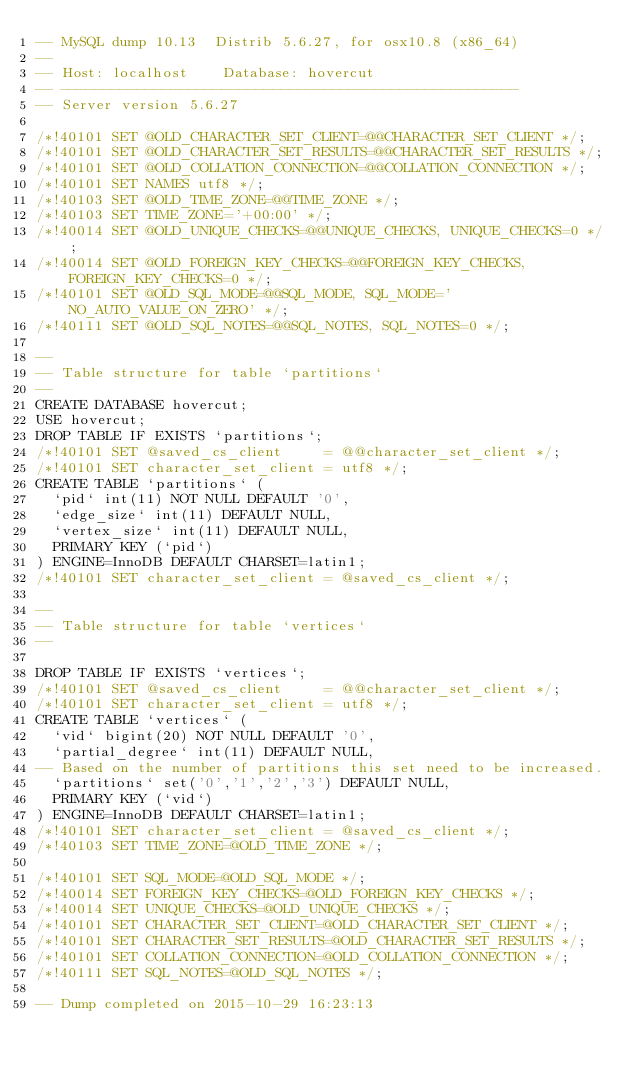Convert code to text. <code><loc_0><loc_0><loc_500><loc_500><_SQL_>-- MySQL dump 10.13  Distrib 5.6.27, for osx10.8 (x86_64)
--
-- Host: localhost    Database: hovercut
-- ------------------------------------------------------
-- Server version	5.6.27

/*!40101 SET @OLD_CHARACTER_SET_CLIENT=@@CHARACTER_SET_CLIENT */;
/*!40101 SET @OLD_CHARACTER_SET_RESULTS=@@CHARACTER_SET_RESULTS */;
/*!40101 SET @OLD_COLLATION_CONNECTION=@@COLLATION_CONNECTION */;
/*!40101 SET NAMES utf8 */;
/*!40103 SET @OLD_TIME_ZONE=@@TIME_ZONE */;
/*!40103 SET TIME_ZONE='+00:00' */;
/*!40014 SET @OLD_UNIQUE_CHECKS=@@UNIQUE_CHECKS, UNIQUE_CHECKS=0 */;
/*!40014 SET @OLD_FOREIGN_KEY_CHECKS=@@FOREIGN_KEY_CHECKS, FOREIGN_KEY_CHECKS=0 */;
/*!40101 SET @OLD_SQL_MODE=@@SQL_MODE, SQL_MODE='NO_AUTO_VALUE_ON_ZERO' */;
/*!40111 SET @OLD_SQL_NOTES=@@SQL_NOTES, SQL_NOTES=0 */;

--
-- Table structure for table `partitions`
--
CREATE DATABASE hovercut;
USE hovercut;
DROP TABLE IF EXISTS `partitions`;
/*!40101 SET @saved_cs_client     = @@character_set_client */;
/*!40101 SET character_set_client = utf8 */;
CREATE TABLE `partitions` (
  `pid` int(11) NOT NULL DEFAULT '0',
  `edge_size` int(11) DEFAULT NULL,
  `vertex_size` int(11) DEFAULT NULL,
  PRIMARY KEY (`pid`)
) ENGINE=InnoDB DEFAULT CHARSET=latin1;
/*!40101 SET character_set_client = @saved_cs_client */;

--
-- Table structure for table `vertices`
--

DROP TABLE IF EXISTS `vertices`;
/*!40101 SET @saved_cs_client     = @@character_set_client */;
/*!40101 SET character_set_client = utf8 */;
CREATE TABLE `vertices` (
  `vid` bigint(20) NOT NULL DEFAULT '0',
  `partial_degree` int(11) DEFAULT NULL,
-- Based on the number of partitions this set need to be increased.
  `partitions` set('0','1','2','3') DEFAULT NULL,
  PRIMARY KEY (`vid`)
) ENGINE=InnoDB DEFAULT CHARSET=latin1;
/*!40101 SET character_set_client = @saved_cs_client */;
/*!40103 SET TIME_ZONE=@OLD_TIME_ZONE */;

/*!40101 SET SQL_MODE=@OLD_SQL_MODE */;
/*!40014 SET FOREIGN_KEY_CHECKS=@OLD_FOREIGN_KEY_CHECKS */;
/*!40014 SET UNIQUE_CHECKS=@OLD_UNIQUE_CHECKS */;
/*!40101 SET CHARACTER_SET_CLIENT=@OLD_CHARACTER_SET_CLIENT */;
/*!40101 SET CHARACTER_SET_RESULTS=@OLD_CHARACTER_SET_RESULTS */;
/*!40101 SET COLLATION_CONNECTION=@OLD_COLLATION_CONNECTION */;
/*!40111 SET SQL_NOTES=@OLD_SQL_NOTES */;

-- Dump completed on 2015-10-29 16:23:13
</code> 